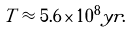<formula> <loc_0><loc_0><loc_500><loc_500>T \approx 5 . 6 \times 1 0 ^ { 8 } y r .</formula> 